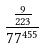Convert formula to latex. <formula><loc_0><loc_0><loc_500><loc_500>\frac { \frac { 9 } { 2 2 3 } } { 7 7 ^ { 4 5 5 } }</formula> 